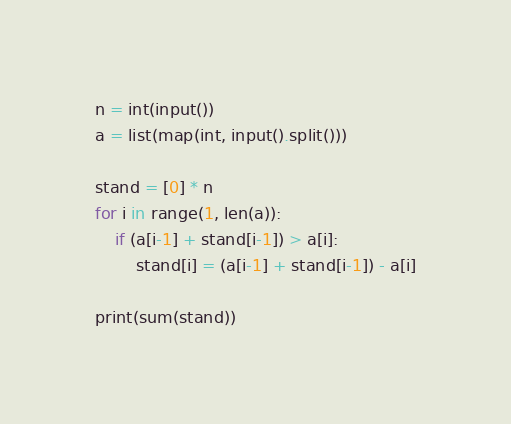Convert code to text. <code><loc_0><loc_0><loc_500><loc_500><_Python_>n = int(input())
a = list(map(int, input().split()))

stand = [0] * n
for i in range(1, len(a)):
    if (a[i-1] + stand[i-1]) > a[i]:
        stand[i] = (a[i-1] + stand[i-1]) - a[i]

print(sum(stand))</code> 